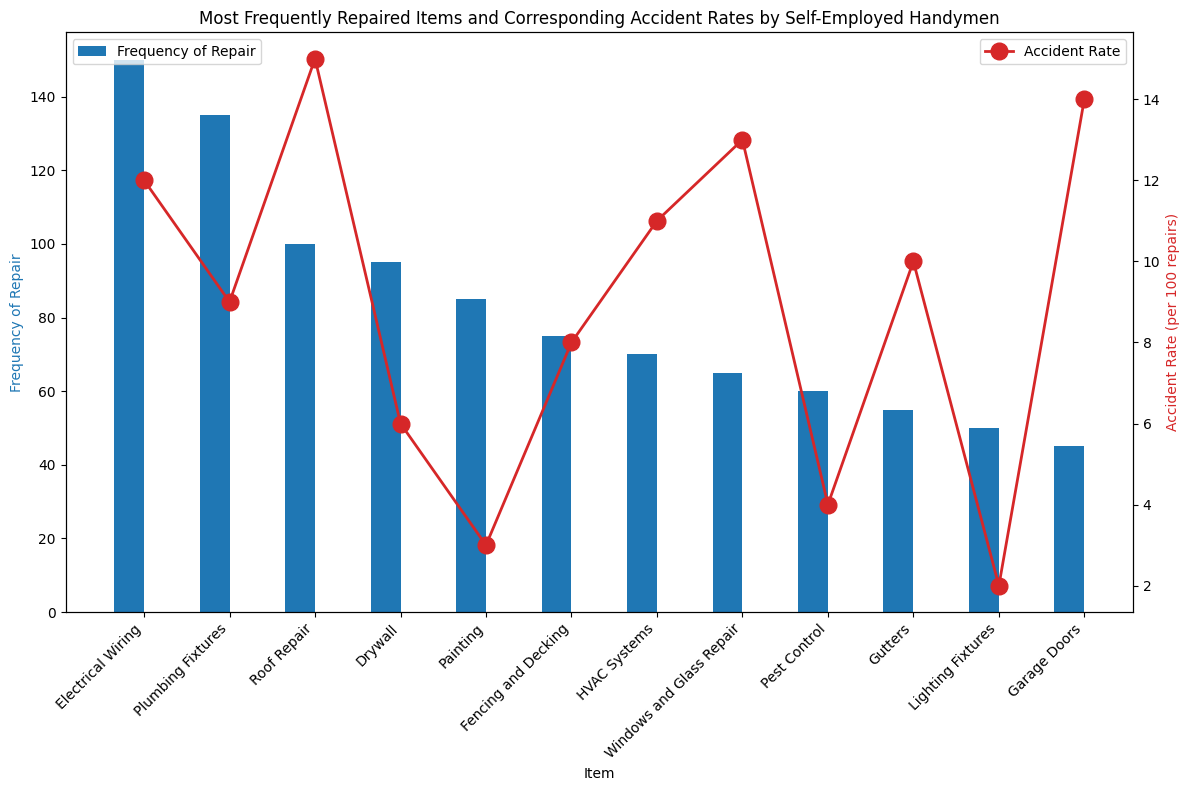What item has the highest frequency of repair? Look at the bar chart to see which item has the tallest blue bar. The tallest blue bar corresponds to Electrical Wiring.
Answer: Electrical Wiring Which item has the lowest accident rate? Look at the red line chart and identify the lowest point. The lowest accident rate (2 per 100 repairs) corresponds to Lighting Fixtures.
Answer: Lighting Fixtures What is the average frequency of repair for Plumbing Fixtures and Roof Repair? Sum the frequencies of repair for Plumbing Fixtures (135) and Roof Repair (100), then divide by 2: (135 + 100) / 2 = 117.5
Answer: 117.5 Which has a higher accident rate, Windows and Glass Repair or Garage Doors? Compare the points on the red line chart for both items. Windows and Glass Repair has an accident rate of 13 per 100 repairs, and Garage Doors has an accident rate of 14 per 100 repairs.
Answer: Garage Doors How much higher is the accident rate for Roof Repair compared to Drywall? Subtract the accident rate for Drywall (6 per 100 repairs) from the accident rate for Roof Repair (15 per 100 repairs): 15 - 6 = 9
Answer: 9 Which item is more frequently repaired, Fencing and Decking or HVAC Systems? Compare the heights of the blue bars for Fencing and Decking (75) and HVAC Systems (70).
Answer: Fencing and Decking What is the total number of repairs for the three items with the highest repair frequencies? Sum the frequencies of repair for Electrical Wiring (150), Plumbing Fixtures (135), and Roof Repair (100): 150 + 135 + 100 = 385
Answer: 385 What is the sum of accident rates for the three least frequently repaired items? Sum the accident rates for Lighting Fixtures (2), Garage Doors (14), and Gutters (10): 2 + 14 + 10 = 26
Answer: 26 Which item has both a high frequency of repair and a relatively low accident rate? Identify items with tall blue bars and lower points on the red line chart. Plumbing Fixtures has a high frequency of repair (135) and a relatively low accident rate (9).
Answer: Plumbing Fixtures 